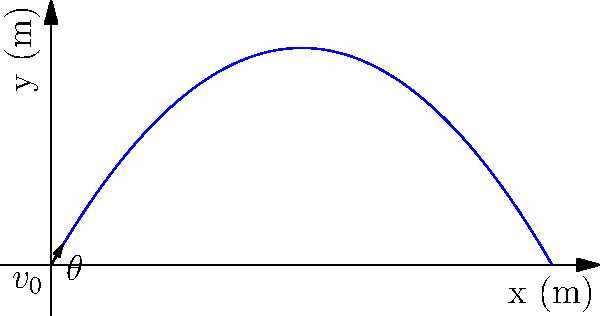A projectile is launched from the origin with an initial velocity $v_0 = 50$ m/s at an angle $\theta = 60°$ above the horizontal. Assuming negligible air resistance and using $g = 9.8$ m/s², determine:

a) The maximum height reached by the projectile.
b) The total time of flight.
c) The horizontal range of the projectile.

Express your answers in terms of $v_0$, $\theta$, and $g$ where possible, then calculate the numerical values. Let's approach this step-by-step:

1) Maximum height:
   a) The vertical component of velocity at the highest point is zero.
   b) Use the equation: $v_y^2 = v_{0y}^2 - 2gy$
   c) $v_{0y} = v_0 \sin\theta$
   d) $0 = (v_0 \sin\theta)^2 - 2gh_{max}$
   e) $h_{max} = \frac{(v_0 \sin\theta)^2}{2g} = \frac{v_0^2 \sin^2\theta}{2g}$
   f) Numerically: $h_{max} = \frac{50^2 \sin^2(60°)}{2(9.8)} \approx 53.1$ m

2) Time of flight:
   a) Total time is twice the time to reach the highest point
   b) Use the equation: $y = v_{0y}t - \frac{1}{2}gt^2$
   c) At the highest point, $y = h_{max}$ and $t = t_{max}$
   d) $h_{max} = v_0 \sin\theta \cdot t_{max} - \frac{1}{2}g(t_{max})^2$
   e) Solving for $t_{max}$: $t_{max} = \frac{v_0 \sin\theta}{g}$
   f) Total time: $t_{total} = 2t_{max} = \frac{2v_0 \sin\theta}{g}$
   g) Numerically: $t_{total} = \frac{2(50)\sin(60°)}{9.8} \approx 8.84$ s

3) Horizontal range:
   a) Use the equation: $x = v_{0x}t$
   b) $v_{0x} = v_0 \cos\theta$
   c) $R = v_0 \cos\theta \cdot t_{total} = v_0 \cos\theta \cdot \frac{2v_0 \sin\theta}{g}$
   d) Simplify: $R = \frac{v_0^2 \sin(2\theta)}{g}$
   e) Numerically: $R = \frac{50^2 \sin(120°)}{9.8} \approx 220.7$ m
Answer: a) $h_{max} = \frac{v_0^2 \sin^2\theta}{2g} \approx 53.1$ m
b) $t_{total} = \frac{2v_0 \sin\theta}{g} \approx 8.84$ s
c) $R = \frac{v_0^2 \sin(2\theta)}{g} \approx 220.7$ m 